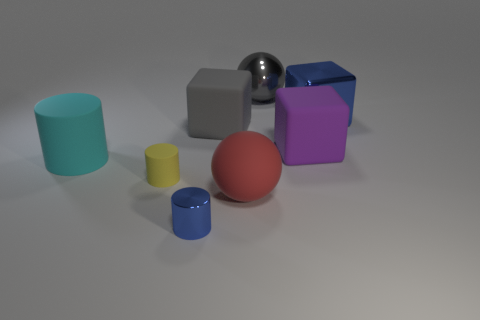What is the shape of the metal object that is the same color as the metallic block?
Your answer should be compact. Cylinder. There is a small blue metal object; how many large purple things are in front of it?
Your answer should be very brief. 0. The large thing that is behind the gray rubber cube and left of the big purple block is made of what material?
Give a very brief answer. Metal. What number of cylinders are purple rubber things or large gray objects?
Provide a succinct answer. 0. What material is the blue thing that is the same shape as the yellow matte thing?
Make the answer very short. Metal. What is the size of the gray object that is the same material as the red sphere?
Ensure brevity in your answer.  Large. There is a blue thing behind the yellow rubber object; is it the same shape as the small thing behind the big red matte thing?
Offer a terse response. No. What is the color of the block that is made of the same material as the large purple thing?
Make the answer very short. Gray. There is a blue metal object that is to the left of the large shiny cube; is it the same size as the object behind the shiny cube?
Offer a terse response. No. What shape is the thing that is both in front of the cyan cylinder and right of the large gray rubber thing?
Your answer should be compact. Sphere. 